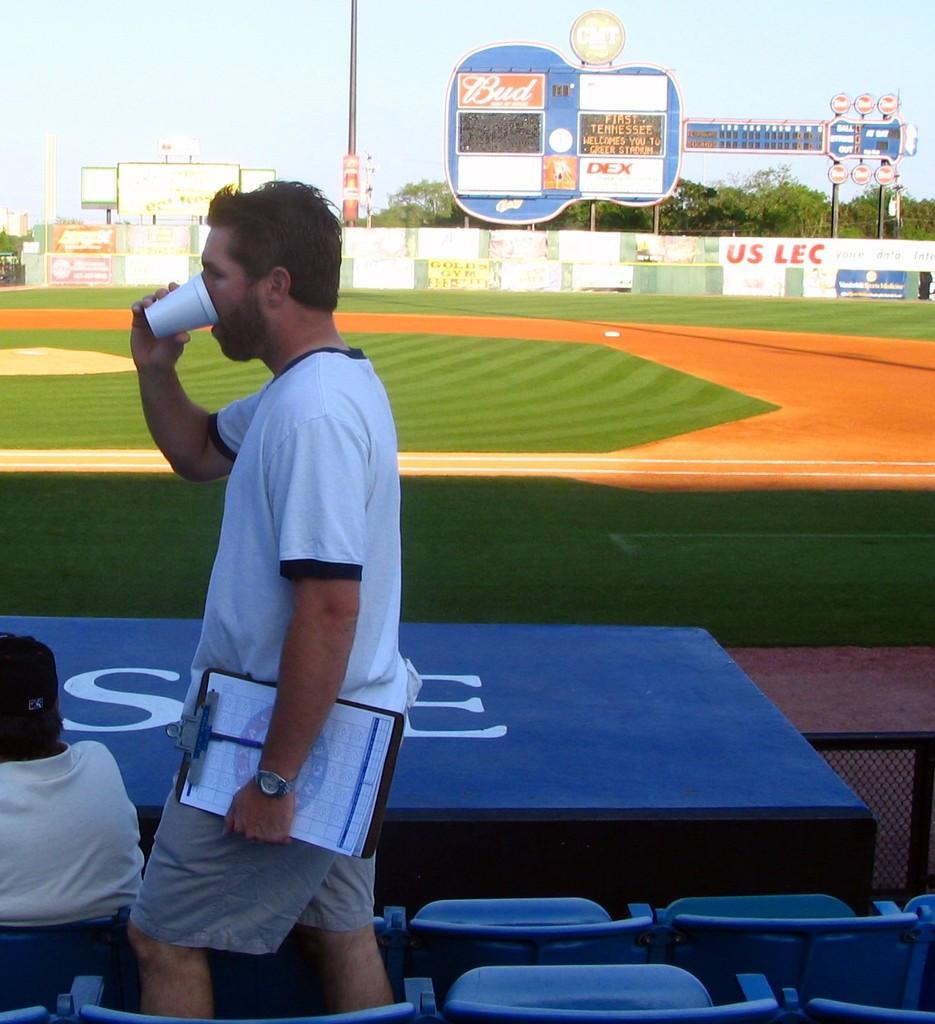<image>
Relay a brief, clear account of the picture shown. man drinking from cup and carrying clipboard in stadium where you can see digital sign showing first tennessee welcomes you to greer stadium 